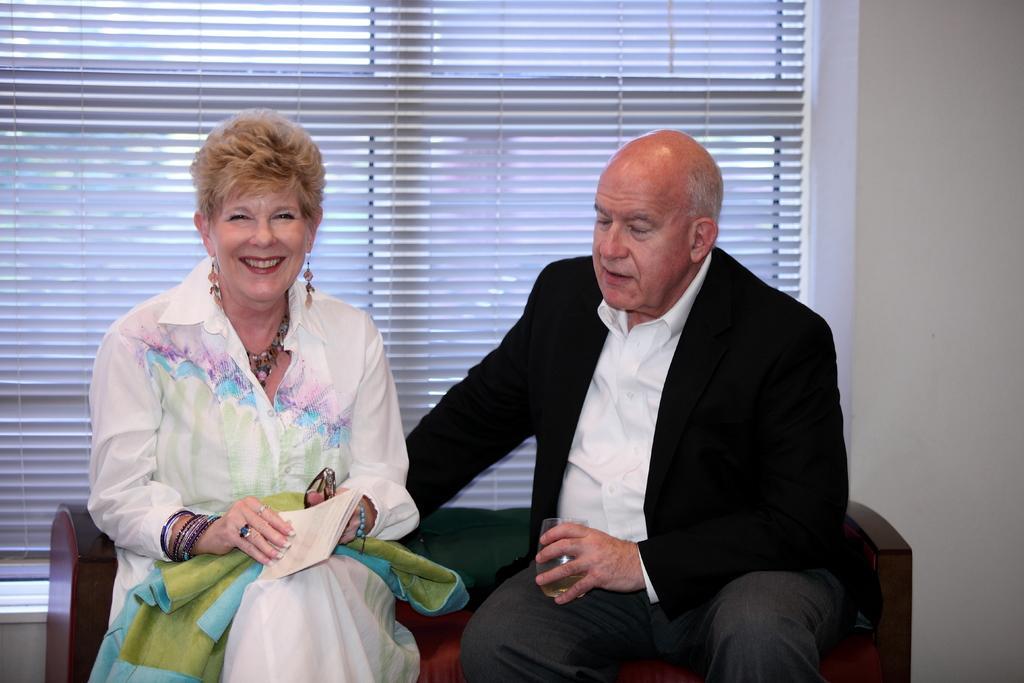In one or two sentences, can you explain what this image depicts? In this image we can see a man and a woman sitting on a sofa. In that the woman is holding a book. On the backside we can see a wall and a window. 